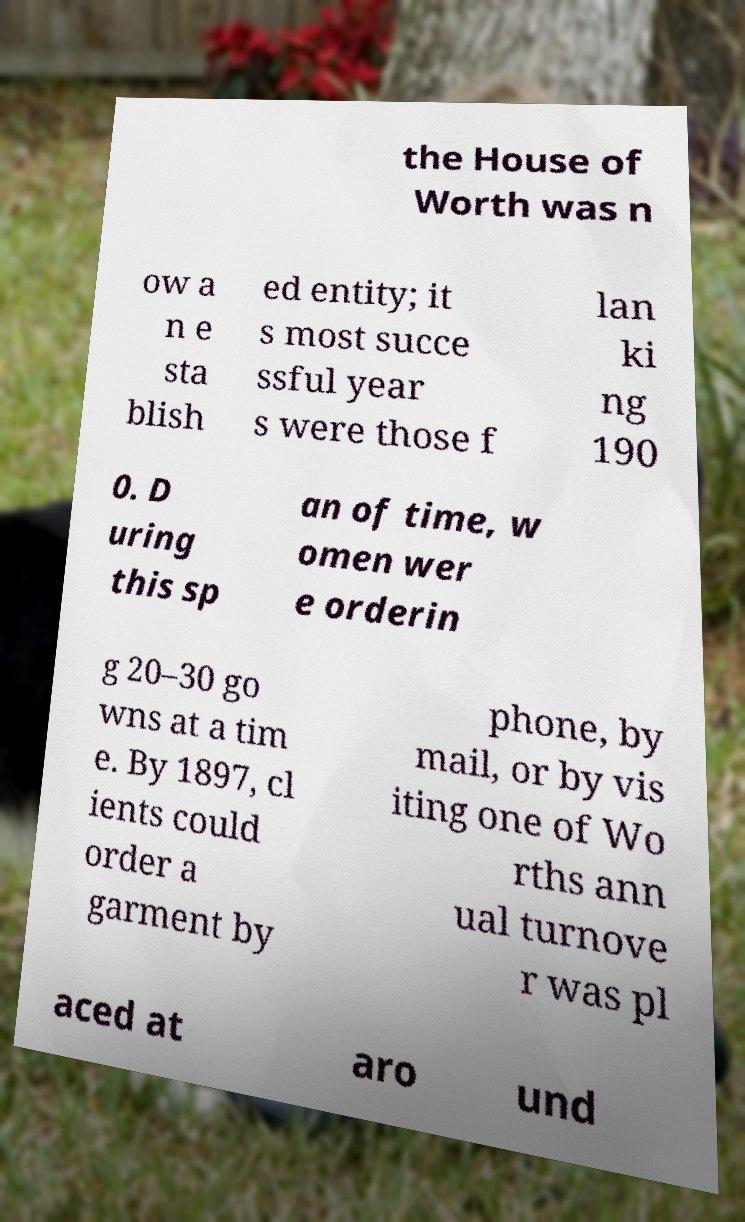Can you read and provide the text displayed in the image?This photo seems to have some interesting text. Can you extract and type it out for me? the House of Worth was n ow a n e sta blish ed entity; it s most succe ssful year s were those f lan ki ng 190 0. D uring this sp an of time, w omen wer e orderin g 20–30 go wns at a tim e. By 1897, cl ients could order a garment by phone, by mail, or by vis iting one of Wo rths ann ual turnove r was pl aced at aro und 